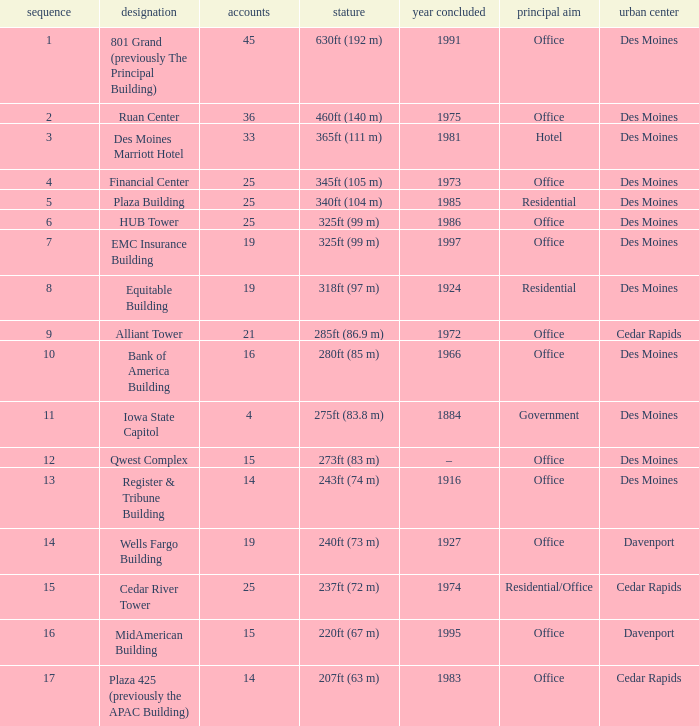What is the total stories that rank number 10? 1.0. 